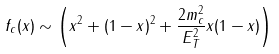Convert formula to latex. <formula><loc_0><loc_0><loc_500><loc_500>f _ { c } ( x ) \sim \left ( x ^ { 2 } + ( 1 - x ) ^ { 2 } + \frac { 2 m _ { c } ^ { 2 } } { E _ { T } ^ { 2 } } x ( 1 - x ) \right )</formula> 